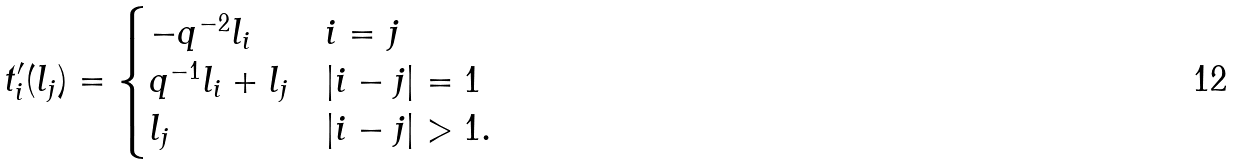Convert formula to latex. <formula><loc_0><loc_0><loc_500><loc_500>t _ { i } ^ { \prime } ( l _ { j } ) = \begin{cases} - q ^ { - 2 } l _ { i } & i = j \\ q ^ { - 1 } l _ { i } + l _ { j } & | i - j | = 1 \\ l _ { j } & | i - j | > 1 . \end{cases}</formula> 